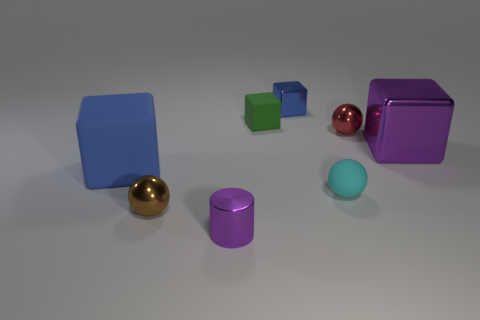Subtract all purple cubes. How many cubes are left? 3 Add 1 big matte cubes. How many objects exist? 9 Subtract all green blocks. How many blocks are left? 3 Subtract 2 spheres. How many spheres are left? 1 Subtract all brown objects. Subtract all purple things. How many objects are left? 5 Add 5 large blue matte cubes. How many large blue matte cubes are left? 6 Add 5 large red metallic objects. How many large red metallic objects exist? 5 Subtract 0 blue spheres. How many objects are left? 8 Subtract all cylinders. How many objects are left? 7 Subtract all gray cylinders. Subtract all yellow spheres. How many cylinders are left? 1 